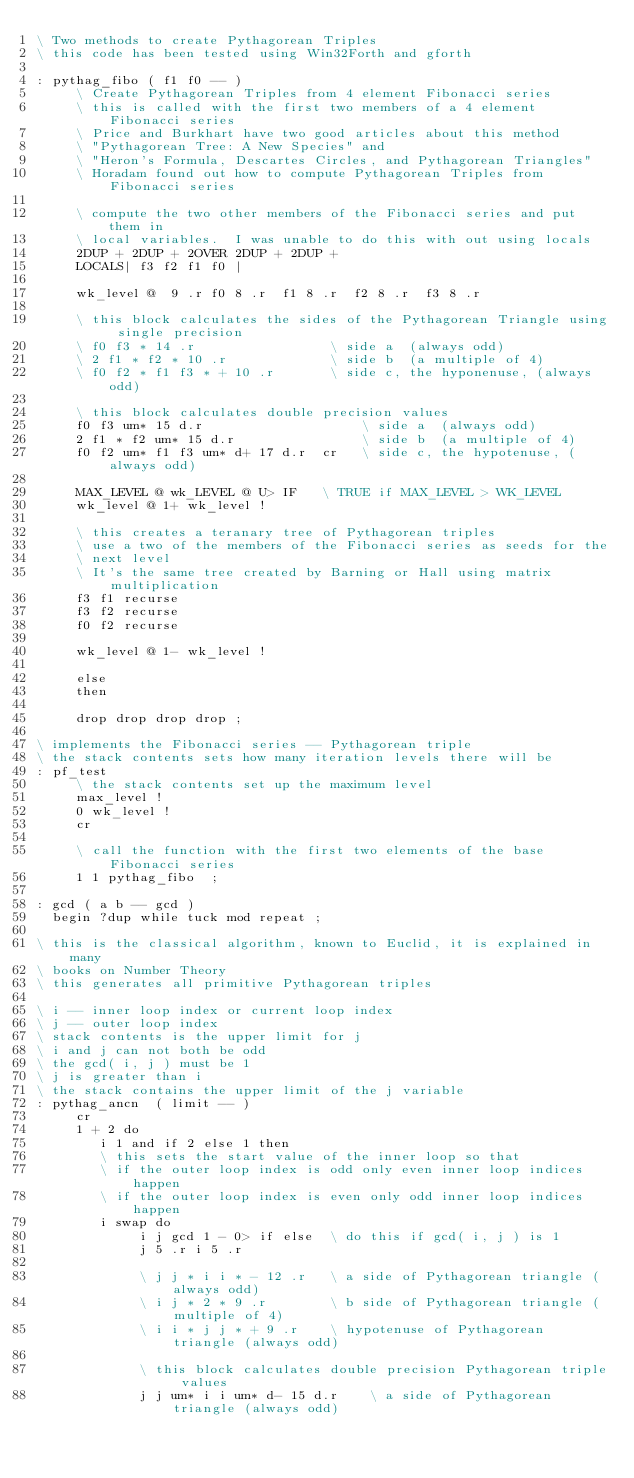Convert code to text. <code><loc_0><loc_0><loc_500><loc_500><_Forth_>\ Two methods to create Pythagorean Triples
\ this code has been tested using Win32Forth and gforth

: pythag_fibo ( f1 f0 -- )
     \ Create Pythagorean Triples from 4 element Fibonacci series
     \ this is called with the first two members of a 4 element Fibonacci series
     \ Price and Burkhart have two good articles about this method
     \ "Pythagorean Tree: A New Species" and
     \ "Heron's Formula, Descartes Circles, and Pythagorean Triangles"
     \ Horadam found out how to compute Pythagorean Triples from Fibonacci series

     \ compute the two other members of the Fibonacci series and put them in
     \ local variables.  I was unable to do this with out using locals
     2DUP + 2DUP + 2OVER 2DUP + 2DUP +
     LOCALS| f3 f2 f1 f0 |

     wk_level @  9 .r f0 8 .r  f1 8 .r  f2 8 .r  f3 8 .r

     \ this block calculates the sides of the Pythagorean Triangle using single precision
     \ f0 f3 * 14 .r                 \ side a  (always odd)
     \ 2 f1 * f2 * 10 .r             \ side b  (a multiple of 4)
     \ f0 f2 * f1 f3 * + 10 .r       \ side c, the hyponenuse, (always odd)

     \ this block calculates double precision values
     f0 f3 um* 15 d.r                    \ side a  (always odd)
     2 f1 * f2 um* 15 d.r                \ side b  (a multiple of 4)
     f0 f2 um* f1 f3 um* d+ 17 d.r  cr   \ side c, the hypotenuse, (always odd)

     MAX_LEVEL @ wk_LEVEL @ U> IF   \ TRUE if MAX_LEVEL > WK_LEVEL
     wk_level @ 1+ wk_level !

     \ this creates a teranary tree of Pythagorean triples
     \ use a two of the members of the Fibonacci series as seeds for the
     \ next level
     \ It's the same tree created by Barning or Hall using matrix multiplication
     f3 f1 recurse
     f3 f2 recurse
     f0 f2 recurse

     wk_level @ 1- wk_level !

     else
     then

     drop drop drop drop ;

\ implements the Fibonacci series -- Pythagorean triple
\ the stack contents sets how many iteration levels there will be
: pf_test
     \ the stack contents set up the maximum level
     max_level !
     0 wk_level !
     cr

     \ call the function with the first two elements of the base Fibonacci series
     1 1 pythag_fibo  ;

: gcd ( a b -- gcd )
  begin ?dup while tuck mod repeat ;

\ this is the classical algorithm, known to Euclid, it is explained in many
\ books on Number Theory
\ this generates all primitive Pythagorean triples

\ i -- inner loop index or current loop index
\ j -- outer loop index
\ stack contents is the upper limit for j
\ i and j can not both be odd
\ the gcd( i, j ) must be 1
\ j is greater than i
\ the stack contains the upper limit of the j variable
: pythag_ancn  ( limit -- )
     cr
     1 + 2 do
        i 1 and if 2 else 1 then
        \ this sets the start value of the inner loop so that
        \ if the outer loop index is odd only even inner loop indices happen
        \ if the outer loop index is even only odd inner loop indices happen
        i swap do
             i j gcd 1 - 0> if else  \ do this if gcd( i, j ) is 1
             j 5 .r i 5 .r

             \ j j * i i * - 12 .r   \ a side of Pythagorean triangle (always odd)
             \ i j * 2 * 9 .r        \ b side of Pythagorean triangle (multiple of 4)
             \ i i * j j * + 9 .r    \ hypotenuse of Pythagorean triangle (always odd)

             \ this block calculates double precision Pythagorean triple values
             j j um* i i um* d- 15 d.r    \ a side of Pythagorean triangle (always odd)</code> 